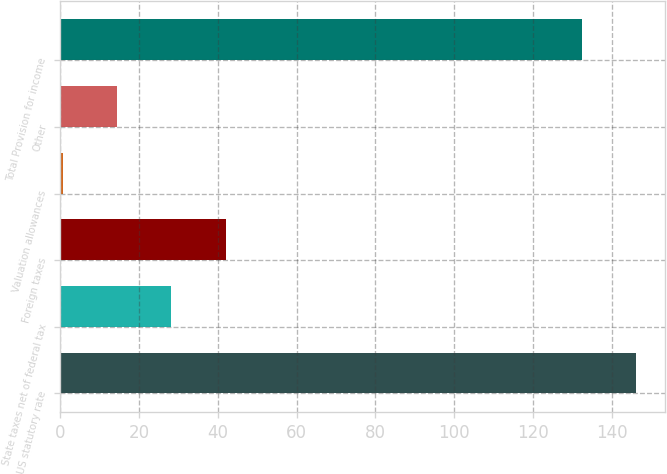Convert chart. <chart><loc_0><loc_0><loc_500><loc_500><bar_chart><fcel>US statutory rate<fcel>State taxes net of federal tax<fcel>Foreign taxes<fcel>Valuation allowances<fcel>Other<fcel>Total Provision for income<nl><fcel>146.27<fcel>28.24<fcel>42.01<fcel>0.7<fcel>14.47<fcel>132.5<nl></chart> 